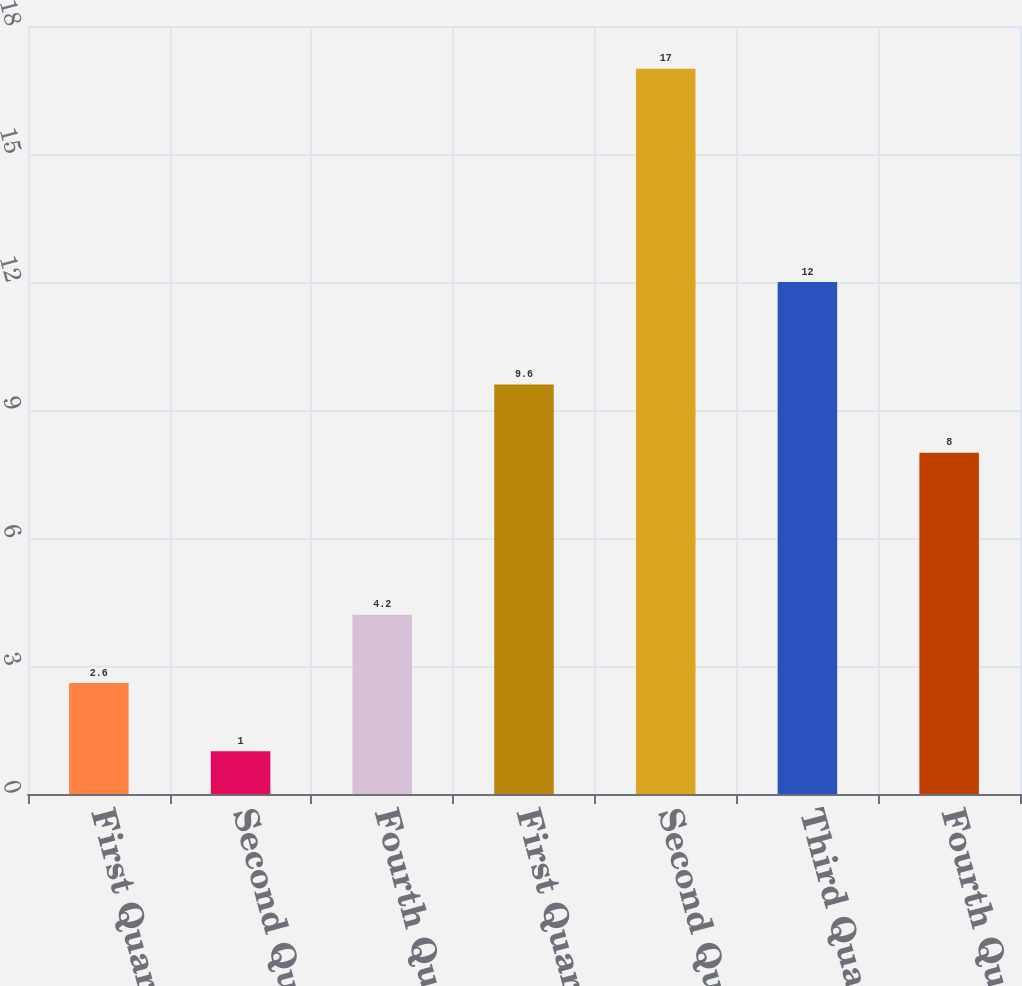Convert chart. <chart><loc_0><loc_0><loc_500><loc_500><bar_chart><fcel>First Quarter 2010<fcel>Second Quarter 2010<fcel>Fourth Quarter 2010<fcel>First Quarter 2009<fcel>Second Quarter 2009<fcel>Third Quarter 2009<fcel>Fourth Quarter 2009<nl><fcel>2.6<fcel>1<fcel>4.2<fcel>9.6<fcel>17<fcel>12<fcel>8<nl></chart> 